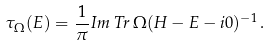Convert formula to latex. <formula><loc_0><loc_0><loc_500><loc_500>\tau _ { \Omega } ( E ) = \frac { 1 } { \pi } I m \, T r \, \Omega ( H - E - i 0 ) ^ { - 1 } \, .</formula> 